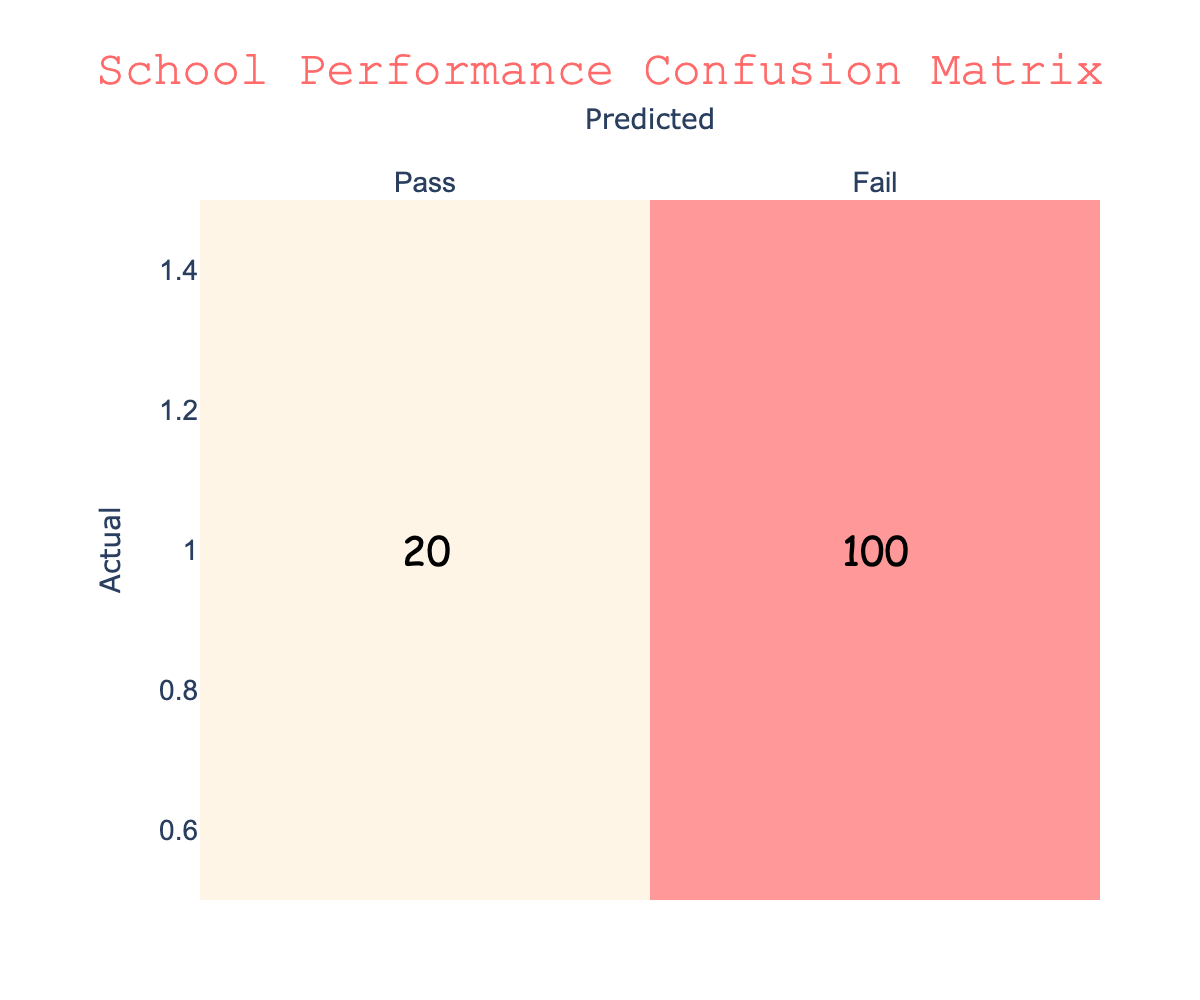What is the total number of students who passed? According to the table, the number of students who passed is indicated in the cell under the 'Pass' row and 'Pass' column, which shows 150 students.
Answer: 150 How many students failed who were predicted to pass? The table shows the number of students who actually failed but were predicted to pass in the cell under the 'Fail' row and 'Pass' column, which is 20.
Answer: 20 What is the number of students who were correctly predicted to fail? The cell under the 'Fail' row and 'Fail' column shows the number of students who were predicted to fail and did indeed fail, which is 100 students.
Answer: 100 What is the total number of students who were predicted to pass? To find the total predicted to pass, we add the number of actual passes (150) to the number of false negatives (30), giving us a total of 150 + 30 = 180.
Answer: 180 What is the percentage of students that passed out of the total number of students? First, we calculate the total number of students by summing all cells: 150 + 30 + 20 + 100 = 300. The percentage of students that passed is then (150 / 300) * 100%, which equals 50%.
Answer: 50% Is the number of students who passed higher than those who failed? To determine this, compare the sum of students who passed (150 + 30 = 180) to those who failed (20 + 100 = 120). Since 180 is greater than 120, the statement is true.
Answer: Yes What is the difference between the number of actual passes and the number of actual fails? The actual number of passes is 150, while the actual number of fails is 120 (20 + 100). The difference is calculated as 150 - 120 = 30.
Answer: 30 How many students were incorrectly predicted to pass? This can be found by looking at the cell under the 'Fail' row and 'Pass' column, which shows that 20 students were incorrectly predicted to pass, but actually failed.
Answer: 20 How many more students were correctly predicted to pass than those correctly predicted to fail? The number of correctly predicted to pass is 150 (in the 'Pass' row and 'Pass' column) and those correctly predicted to fail is 100 (in the 'Fail' row and 'Fail' column). The difference is 150 - 100 = 50.
Answer: 50 